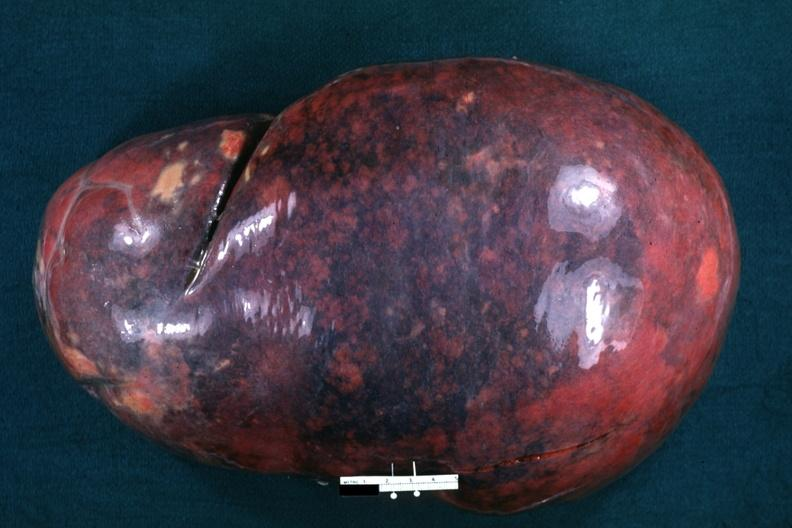what is present?
Answer the question using a single word or phrase. Chronic myelogenous leukemia 